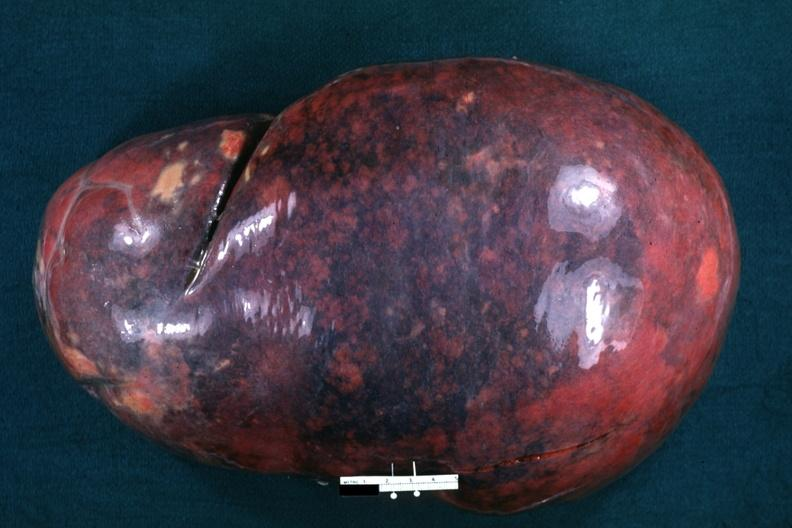what is present?
Answer the question using a single word or phrase. Chronic myelogenous leukemia 